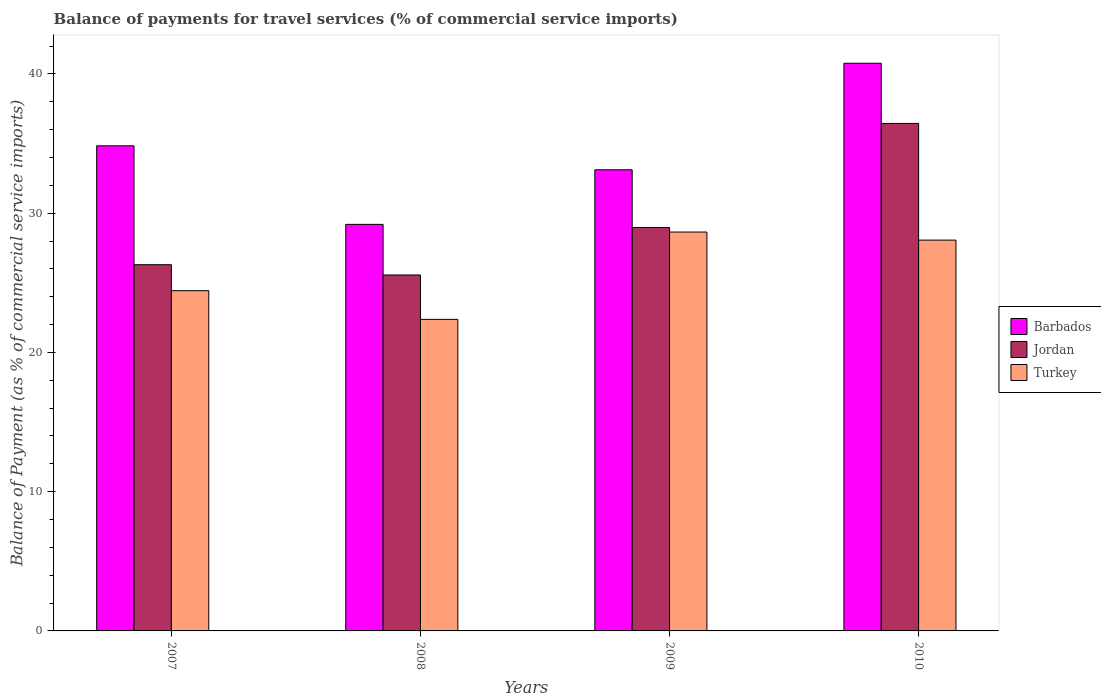How many different coloured bars are there?
Keep it short and to the point. 3. How many groups of bars are there?
Make the answer very short. 4. Are the number of bars per tick equal to the number of legend labels?
Your answer should be very brief. Yes. How many bars are there on the 4th tick from the right?
Keep it short and to the point. 3. In how many cases, is the number of bars for a given year not equal to the number of legend labels?
Provide a succinct answer. 0. What is the balance of payments for travel services in Jordan in 2007?
Your answer should be compact. 26.3. Across all years, what is the maximum balance of payments for travel services in Barbados?
Keep it short and to the point. 40.77. Across all years, what is the minimum balance of payments for travel services in Turkey?
Your answer should be very brief. 22.37. In which year was the balance of payments for travel services in Turkey minimum?
Make the answer very short. 2008. What is the total balance of payments for travel services in Barbados in the graph?
Provide a succinct answer. 137.92. What is the difference between the balance of payments for travel services in Turkey in 2007 and that in 2008?
Your answer should be compact. 2.06. What is the difference between the balance of payments for travel services in Barbados in 2008 and the balance of payments for travel services in Turkey in 2010?
Provide a succinct answer. 1.13. What is the average balance of payments for travel services in Jordan per year?
Provide a short and direct response. 29.32. In the year 2007, what is the difference between the balance of payments for travel services in Barbados and balance of payments for travel services in Turkey?
Ensure brevity in your answer.  10.4. In how many years, is the balance of payments for travel services in Barbados greater than 10 %?
Give a very brief answer. 4. What is the ratio of the balance of payments for travel services in Jordan in 2008 to that in 2010?
Your answer should be compact. 0.7. What is the difference between the highest and the second highest balance of payments for travel services in Turkey?
Your answer should be very brief. 0.58. What is the difference between the highest and the lowest balance of payments for travel services in Barbados?
Your response must be concise. 11.57. What does the 2nd bar from the left in 2008 represents?
Make the answer very short. Jordan. What does the 2nd bar from the right in 2008 represents?
Your response must be concise. Jordan. Is it the case that in every year, the sum of the balance of payments for travel services in Barbados and balance of payments for travel services in Turkey is greater than the balance of payments for travel services in Jordan?
Ensure brevity in your answer.  Yes. How many bars are there?
Offer a terse response. 12. How many years are there in the graph?
Your answer should be compact. 4. Are the values on the major ticks of Y-axis written in scientific E-notation?
Keep it short and to the point. No. Does the graph contain any zero values?
Your answer should be compact. No. Where does the legend appear in the graph?
Your answer should be compact. Center right. How are the legend labels stacked?
Keep it short and to the point. Vertical. What is the title of the graph?
Offer a terse response. Balance of payments for travel services (% of commercial service imports). Does "Finland" appear as one of the legend labels in the graph?
Your response must be concise. No. What is the label or title of the X-axis?
Your response must be concise. Years. What is the label or title of the Y-axis?
Offer a terse response. Balance of Payment (as % of commercial service imports). What is the Balance of Payment (as % of commercial service imports) of Barbados in 2007?
Your answer should be very brief. 34.84. What is the Balance of Payment (as % of commercial service imports) in Jordan in 2007?
Provide a succinct answer. 26.3. What is the Balance of Payment (as % of commercial service imports) of Turkey in 2007?
Your response must be concise. 24.44. What is the Balance of Payment (as % of commercial service imports) of Barbados in 2008?
Provide a succinct answer. 29.2. What is the Balance of Payment (as % of commercial service imports) of Jordan in 2008?
Provide a succinct answer. 25.56. What is the Balance of Payment (as % of commercial service imports) of Turkey in 2008?
Make the answer very short. 22.37. What is the Balance of Payment (as % of commercial service imports) of Barbados in 2009?
Keep it short and to the point. 33.12. What is the Balance of Payment (as % of commercial service imports) in Jordan in 2009?
Provide a short and direct response. 28.97. What is the Balance of Payment (as % of commercial service imports) in Turkey in 2009?
Give a very brief answer. 28.65. What is the Balance of Payment (as % of commercial service imports) of Barbados in 2010?
Provide a short and direct response. 40.77. What is the Balance of Payment (as % of commercial service imports) of Jordan in 2010?
Make the answer very short. 36.44. What is the Balance of Payment (as % of commercial service imports) in Turkey in 2010?
Keep it short and to the point. 28.07. Across all years, what is the maximum Balance of Payment (as % of commercial service imports) of Barbados?
Provide a succinct answer. 40.77. Across all years, what is the maximum Balance of Payment (as % of commercial service imports) in Jordan?
Your answer should be compact. 36.44. Across all years, what is the maximum Balance of Payment (as % of commercial service imports) of Turkey?
Offer a terse response. 28.65. Across all years, what is the minimum Balance of Payment (as % of commercial service imports) in Barbados?
Your response must be concise. 29.2. Across all years, what is the minimum Balance of Payment (as % of commercial service imports) in Jordan?
Offer a terse response. 25.56. Across all years, what is the minimum Balance of Payment (as % of commercial service imports) in Turkey?
Give a very brief answer. 22.37. What is the total Balance of Payment (as % of commercial service imports) in Barbados in the graph?
Provide a succinct answer. 137.92. What is the total Balance of Payment (as % of commercial service imports) of Jordan in the graph?
Give a very brief answer. 117.28. What is the total Balance of Payment (as % of commercial service imports) in Turkey in the graph?
Ensure brevity in your answer.  103.52. What is the difference between the Balance of Payment (as % of commercial service imports) in Barbados in 2007 and that in 2008?
Your answer should be very brief. 5.64. What is the difference between the Balance of Payment (as % of commercial service imports) in Jordan in 2007 and that in 2008?
Provide a succinct answer. 0.74. What is the difference between the Balance of Payment (as % of commercial service imports) of Turkey in 2007 and that in 2008?
Provide a succinct answer. 2.06. What is the difference between the Balance of Payment (as % of commercial service imports) in Barbados in 2007 and that in 2009?
Provide a succinct answer. 1.72. What is the difference between the Balance of Payment (as % of commercial service imports) of Jordan in 2007 and that in 2009?
Provide a short and direct response. -2.67. What is the difference between the Balance of Payment (as % of commercial service imports) in Turkey in 2007 and that in 2009?
Provide a succinct answer. -4.21. What is the difference between the Balance of Payment (as % of commercial service imports) of Barbados in 2007 and that in 2010?
Give a very brief answer. -5.93. What is the difference between the Balance of Payment (as % of commercial service imports) in Jordan in 2007 and that in 2010?
Offer a very short reply. -10.15. What is the difference between the Balance of Payment (as % of commercial service imports) in Turkey in 2007 and that in 2010?
Give a very brief answer. -3.63. What is the difference between the Balance of Payment (as % of commercial service imports) in Barbados in 2008 and that in 2009?
Ensure brevity in your answer.  -3.92. What is the difference between the Balance of Payment (as % of commercial service imports) of Jordan in 2008 and that in 2009?
Your answer should be compact. -3.41. What is the difference between the Balance of Payment (as % of commercial service imports) in Turkey in 2008 and that in 2009?
Make the answer very short. -6.27. What is the difference between the Balance of Payment (as % of commercial service imports) of Barbados in 2008 and that in 2010?
Offer a very short reply. -11.57. What is the difference between the Balance of Payment (as % of commercial service imports) of Jordan in 2008 and that in 2010?
Your answer should be compact. -10.88. What is the difference between the Balance of Payment (as % of commercial service imports) in Turkey in 2008 and that in 2010?
Give a very brief answer. -5.69. What is the difference between the Balance of Payment (as % of commercial service imports) in Barbados in 2009 and that in 2010?
Provide a short and direct response. -7.65. What is the difference between the Balance of Payment (as % of commercial service imports) in Jordan in 2009 and that in 2010?
Your response must be concise. -7.47. What is the difference between the Balance of Payment (as % of commercial service imports) in Turkey in 2009 and that in 2010?
Keep it short and to the point. 0.58. What is the difference between the Balance of Payment (as % of commercial service imports) in Barbados in 2007 and the Balance of Payment (as % of commercial service imports) in Jordan in 2008?
Keep it short and to the point. 9.28. What is the difference between the Balance of Payment (as % of commercial service imports) of Barbados in 2007 and the Balance of Payment (as % of commercial service imports) of Turkey in 2008?
Your answer should be very brief. 12.46. What is the difference between the Balance of Payment (as % of commercial service imports) in Jordan in 2007 and the Balance of Payment (as % of commercial service imports) in Turkey in 2008?
Offer a very short reply. 3.93. What is the difference between the Balance of Payment (as % of commercial service imports) of Barbados in 2007 and the Balance of Payment (as % of commercial service imports) of Jordan in 2009?
Offer a terse response. 5.86. What is the difference between the Balance of Payment (as % of commercial service imports) in Barbados in 2007 and the Balance of Payment (as % of commercial service imports) in Turkey in 2009?
Keep it short and to the point. 6.19. What is the difference between the Balance of Payment (as % of commercial service imports) in Jordan in 2007 and the Balance of Payment (as % of commercial service imports) in Turkey in 2009?
Ensure brevity in your answer.  -2.35. What is the difference between the Balance of Payment (as % of commercial service imports) of Barbados in 2007 and the Balance of Payment (as % of commercial service imports) of Jordan in 2010?
Offer a terse response. -1.61. What is the difference between the Balance of Payment (as % of commercial service imports) of Barbados in 2007 and the Balance of Payment (as % of commercial service imports) of Turkey in 2010?
Keep it short and to the point. 6.77. What is the difference between the Balance of Payment (as % of commercial service imports) in Jordan in 2007 and the Balance of Payment (as % of commercial service imports) in Turkey in 2010?
Provide a succinct answer. -1.77. What is the difference between the Balance of Payment (as % of commercial service imports) in Barbados in 2008 and the Balance of Payment (as % of commercial service imports) in Jordan in 2009?
Keep it short and to the point. 0.22. What is the difference between the Balance of Payment (as % of commercial service imports) in Barbados in 2008 and the Balance of Payment (as % of commercial service imports) in Turkey in 2009?
Your answer should be compact. 0.55. What is the difference between the Balance of Payment (as % of commercial service imports) of Jordan in 2008 and the Balance of Payment (as % of commercial service imports) of Turkey in 2009?
Make the answer very short. -3.08. What is the difference between the Balance of Payment (as % of commercial service imports) in Barbados in 2008 and the Balance of Payment (as % of commercial service imports) in Jordan in 2010?
Offer a terse response. -7.25. What is the difference between the Balance of Payment (as % of commercial service imports) in Barbados in 2008 and the Balance of Payment (as % of commercial service imports) in Turkey in 2010?
Offer a very short reply. 1.13. What is the difference between the Balance of Payment (as % of commercial service imports) in Jordan in 2008 and the Balance of Payment (as % of commercial service imports) in Turkey in 2010?
Your answer should be very brief. -2.5. What is the difference between the Balance of Payment (as % of commercial service imports) of Barbados in 2009 and the Balance of Payment (as % of commercial service imports) of Jordan in 2010?
Offer a very short reply. -3.33. What is the difference between the Balance of Payment (as % of commercial service imports) of Barbados in 2009 and the Balance of Payment (as % of commercial service imports) of Turkey in 2010?
Your response must be concise. 5.05. What is the difference between the Balance of Payment (as % of commercial service imports) of Jordan in 2009 and the Balance of Payment (as % of commercial service imports) of Turkey in 2010?
Offer a terse response. 0.91. What is the average Balance of Payment (as % of commercial service imports) of Barbados per year?
Give a very brief answer. 34.48. What is the average Balance of Payment (as % of commercial service imports) in Jordan per year?
Your answer should be very brief. 29.32. What is the average Balance of Payment (as % of commercial service imports) of Turkey per year?
Your answer should be compact. 25.88. In the year 2007, what is the difference between the Balance of Payment (as % of commercial service imports) in Barbados and Balance of Payment (as % of commercial service imports) in Jordan?
Your response must be concise. 8.54. In the year 2007, what is the difference between the Balance of Payment (as % of commercial service imports) in Barbados and Balance of Payment (as % of commercial service imports) in Turkey?
Offer a very short reply. 10.4. In the year 2007, what is the difference between the Balance of Payment (as % of commercial service imports) of Jordan and Balance of Payment (as % of commercial service imports) of Turkey?
Your response must be concise. 1.86. In the year 2008, what is the difference between the Balance of Payment (as % of commercial service imports) of Barbados and Balance of Payment (as % of commercial service imports) of Jordan?
Provide a succinct answer. 3.63. In the year 2008, what is the difference between the Balance of Payment (as % of commercial service imports) of Barbados and Balance of Payment (as % of commercial service imports) of Turkey?
Your answer should be compact. 6.82. In the year 2008, what is the difference between the Balance of Payment (as % of commercial service imports) in Jordan and Balance of Payment (as % of commercial service imports) in Turkey?
Offer a very short reply. 3.19. In the year 2009, what is the difference between the Balance of Payment (as % of commercial service imports) of Barbados and Balance of Payment (as % of commercial service imports) of Jordan?
Your answer should be very brief. 4.14. In the year 2009, what is the difference between the Balance of Payment (as % of commercial service imports) in Barbados and Balance of Payment (as % of commercial service imports) in Turkey?
Your answer should be compact. 4.47. In the year 2009, what is the difference between the Balance of Payment (as % of commercial service imports) of Jordan and Balance of Payment (as % of commercial service imports) of Turkey?
Provide a succinct answer. 0.33. In the year 2010, what is the difference between the Balance of Payment (as % of commercial service imports) in Barbados and Balance of Payment (as % of commercial service imports) in Jordan?
Provide a short and direct response. 4.32. In the year 2010, what is the difference between the Balance of Payment (as % of commercial service imports) of Barbados and Balance of Payment (as % of commercial service imports) of Turkey?
Your answer should be very brief. 12.7. In the year 2010, what is the difference between the Balance of Payment (as % of commercial service imports) of Jordan and Balance of Payment (as % of commercial service imports) of Turkey?
Offer a terse response. 8.38. What is the ratio of the Balance of Payment (as % of commercial service imports) of Barbados in 2007 to that in 2008?
Make the answer very short. 1.19. What is the ratio of the Balance of Payment (as % of commercial service imports) in Jordan in 2007 to that in 2008?
Give a very brief answer. 1.03. What is the ratio of the Balance of Payment (as % of commercial service imports) in Turkey in 2007 to that in 2008?
Your answer should be compact. 1.09. What is the ratio of the Balance of Payment (as % of commercial service imports) in Barbados in 2007 to that in 2009?
Provide a short and direct response. 1.05. What is the ratio of the Balance of Payment (as % of commercial service imports) of Jordan in 2007 to that in 2009?
Provide a succinct answer. 0.91. What is the ratio of the Balance of Payment (as % of commercial service imports) in Turkey in 2007 to that in 2009?
Keep it short and to the point. 0.85. What is the ratio of the Balance of Payment (as % of commercial service imports) of Barbados in 2007 to that in 2010?
Provide a short and direct response. 0.85. What is the ratio of the Balance of Payment (as % of commercial service imports) in Jordan in 2007 to that in 2010?
Provide a short and direct response. 0.72. What is the ratio of the Balance of Payment (as % of commercial service imports) of Turkey in 2007 to that in 2010?
Offer a terse response. 0.87. What is the ratio of the Balance of Payment (as % of commercial service imports) in Barbados in 2008 to that in 2009?
Provide a succinct answer. 0.88. What is the ratio of the Balance of Payment (as % of commercial service imports) of Jordan in 2008 to that in 2009?
Give a very brief answer. 0.88. What is the ratio of the Balance of Payment (as % of commercial service imports) of Turkey in 2008 to that in 2009?
Your answer should be very brief. 0.78. What is the ratio of the Balance of Payment (as % of commercial service imports) of Barbados in 2008 to that in 2010?
Offer a very short reply. 0.72. What is the ratio of the Balance of Payment (as % of commercial service imports) of Jordan in 2008 to that in 2010?
Your answer should be compact. 0.7. What is the ratio of the Balance of Payment (as % of commercial service imports) in Turkey in 2008 to that in 2010?
Your answer should be very brief. 0.8. What is the ratio of the Balance of Payment (as % of commercial service imports) of Barbados in 2009 to that in 2010?
Provide a short and direct response. 0.81. What is the ratio of the Balance of Payment (as % of commercial service imports) in Jordan in 2009 to that in 2010?
Your answer should be compact. 0.8. What is the ratio of the Balance of Payment (as % of commercial service imports) of Turkey in 2009 to that in 2010?
Give a very brief answer. 1.02. What is the difference between the highest and the second highest Balance of Payment (as % of commercial service imports) of Barbados?
Offer a terse response. 5.93. What is the difference between the highest and the second highest Balance of Payment (as % of commercial service imports) of Jordan?
Offer a terse response. 7.47. What is the difference between the highest and the second highest Balance of Payment (as % of commercial service imports) in Turkey?
Your response must be concise. 0.58. What is the difference between the highest and the lowest Balance of Payment (as % of commercial service imports) in Barbados?
Make the answer very short. 11.57. What is the difference between the highest and the lowest Balance of Payment (as % of commercial service imports) of Jordan?
Give a very brief answer. 10.88. What is the difference between the highest and the lowest Balance of Payment (as % of commercial service imports) of Turkey?
Ensure brevity in your answer.  6.27. 